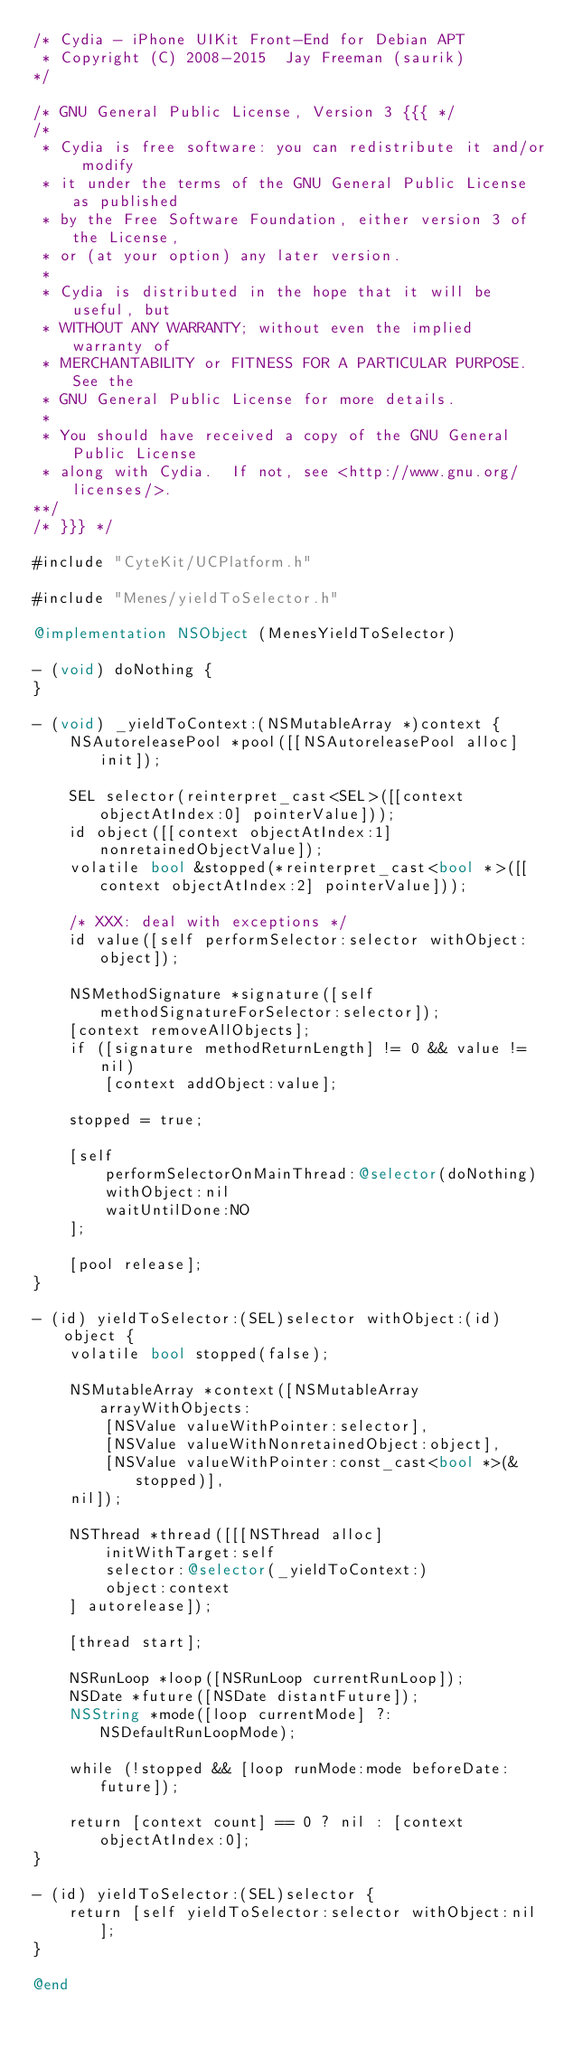<code> <loc_0><loc_0><loc_500><loc_500><_ObjectiveC_>/* Cydia - iPhone UIKit Front-End for Debian APT
 * Copyright (C) 2008-2015  Jay Freeman (saurik)
*/

/* GNU General Public License, Version 3 {{{ */
/*
 * Cydia is free software: you can redistribute it and/or modify
 * it under the terms of the GNU General Public License as published
 * by the Free Software Foundation, either version 3 of the License,
 * or (at your option) any later version.
 *
 * Cydia is distributed in the hope that it will be useful, but
 * WITHOUT ANY WARRANTY; without even the implied warranty of
 * MERCHANTABILITY or FITNESS FOR A PARTICULAR PURPOSE.  See the
 * GNU General Public License for more details.
 *
 * You should have received a copy of the GNU General Public License
 * along with Cydia.  If not, see <http://www.gnu.org/licenses/>.
**/
/* }}} */

#include "CyteKit/UCPlatform.h"

#include "Menes/yieldToSelector.h"

@implementation NSObject (MenesYieldToSelector)

- (void) doNothing {
}

- (void) _yieldToContext:(NSMutableArray *)context {
    NSAutoreleasePool *pool([[NSAutoreleasePool alloc] init]);

    SEL selector(reinterpret_cast<SEL>([[context objectAtIndex:0] pointerValue]));
    id object([[context objectAtIndex:1] nonretainedObjectValue]);
    volatile bool &stopped(*reinterpret_cast<bool *>([[context objectAtIndex:2] pointerValue]));

    /* XXX: deal with exceptions */
    id value([self performSelector:selector withObject:object]);

    NSMethodSignature *signature([self methodSignatureForSelector:selector]);
    [context removeAllObjects];
    if ([signature methodReturnLength] != 0 && value != nil)
        [context addObject:value];

    stopped = true;

    [self
        performSelectorOnMainThread:@selector(doNothing)
        withObject:nil
        waitUntilDone:NO
    ];

    [pool release];
}

- (id) yieldToSelector:(SEL)selector withObject:(id)object {
    volatile bool stopped(false);

    NSMutableArray *context([NSMutableArray arrayWithObjects:
        [NSValue valueWithPointer:selector],
        [NSValue valueWithNonretainedObject:object],
        [NSValue valueWithPointer:const_cast<bool *>(&stopped)],
    nil]);

    NSThread *thread([[[NSThread alloc]
        initWithTarget:self
        selector:@selector(_yieldToContext:)
        object:context
    ] autorelease]);

    [thread start];

    NSRunLoop *loop([NSRunLoop currentRunLoop]);
    NSDate *future([NSDate distantFuture]);
    NSString *mode([loop currentMode] ?: NSDefaultRunLoopMode);

    while (!stopped && [loop runMode:mode beforeDate:future]);

    return [context count] == 0 ? nil : [context objectAtIndex:0];
}

- (id) yieldToSelector:(SEL)selector {
    return [self yieldToSelector:selector withObject:nil];
}

@end
</code> 